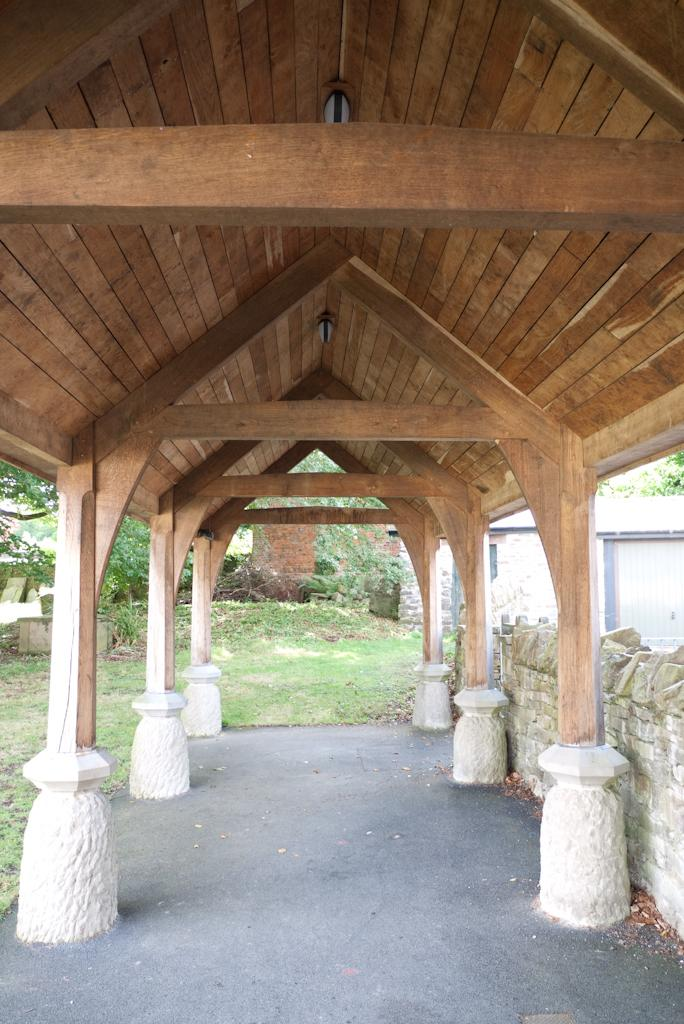What type of vegetation can be seen in the background of the image? There is grass and trees in the background of the image. Can you describe the natural setting in the image? The natural setting in the image includes grass and trees in the background. What color is the crayon being used to draw the trees in the image? There is no crayon present in the image, and the trees are not being drawn. How many eyes can be seen on the grass in the image? There are no eyes present in the image, as the subject is vegetation and not living beings. 